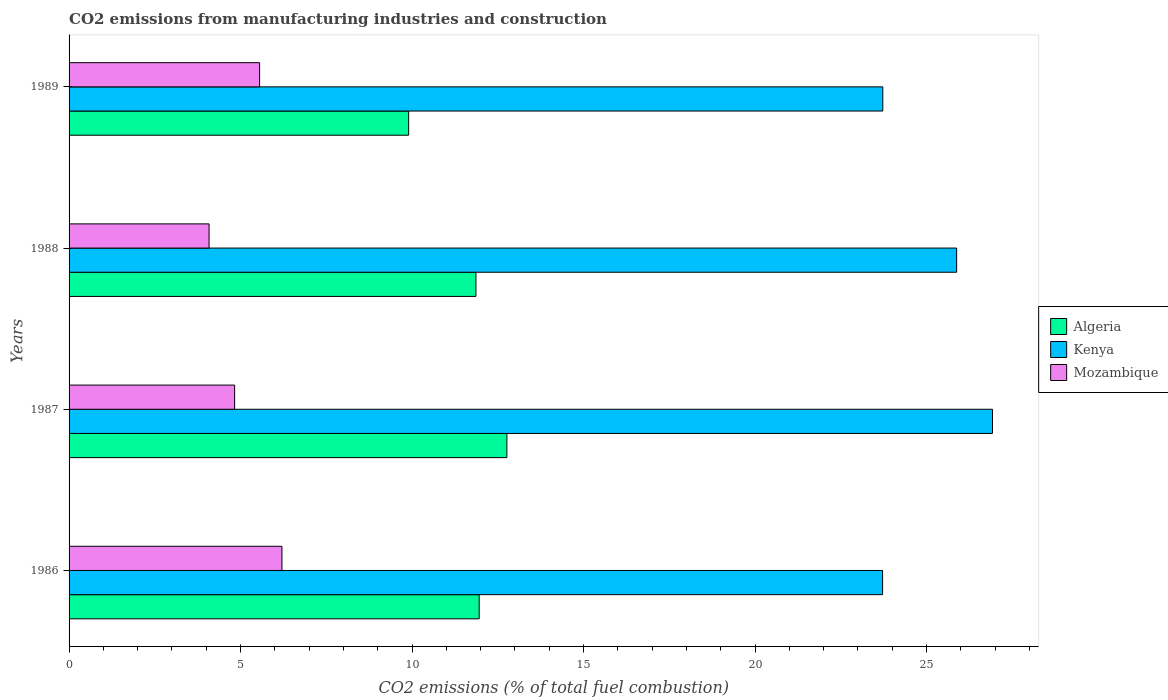How many groups of bars are there?
Your response must be concise. 4. Are the number of bars per tick equal to the number of legend labels?
Make the answer very short. Yes. Are the number of bars on each tick of the Y-axis equal?
Your response must be concise. Yes. How many bars are there on the 3rd tick from the top?
Offer a terse response. 3. What is the label of the 2nd group of bars from the top?
Offer a terse response. 1988. In how many cases, is the number of bars for a given year not equal to the number of legend labels?
Make the answer very short. 0. What is the amount of CO2 emitted in Mozambique in 1989?
Your response must be concise. 5.56. Across all years, what is the maximum amount of CO2 emitted in Algeria?
Provide a short and direct response. 12.77. Across all years, what is the minimum amount of CO2 emitted in Kenya?
Make the answer very short. 23.72. What is the total amount of CO2 emitted in Mozambique in the graph?
Make the answer very short. 20.67. What is the difference between the amount of CO2 emitted in Mozambique in 1986 and that in 1989?
Provide a succinct answer. 0.65. What is the difference between the amount of CO2 emitted in Mozambique in 1988 and the amount of CO2 emitted in Kenya in 1989?
Provide a succinct answer. -19.64. What is the average amount of CO2 emitted in Algeria per year?
Provide a short and direct response. 11.62. In the year 1989, what is the difference between the amount of CO2 emitted in Mozambique and amount of CO2 emitted in Algeria?
Your answer should be compact. -4.35. In how many years, is the amount of CO2 emitted in Kenya greater than 12 %?
Keep it short and to the point. 4. What is the ratio of the amount of CO2 emitted in Kenya in 1986 to that in 1988?
Give a very brief answer. 0.92. Is the difference between the amount of CO2 emitted in Mozambique in 1986 and 1988 greater than the difference between the amount of CO2 emitted in Algeria in 1986 and 1988?
Ensure brevity in your answer.  Yes. What is the difference between the highest and the second highest amount of CO2 emitted in Mozambique?
Your answer should be compact. 0.65. What is the difference between the highest and the lowest amount of CO2 emitted in Algeria?
Your answer should be compact. 2.86. In how many years, is the amount of CO2 emitted in Algeria greater than the average amount of CO2 emitted in Algeria taken over all years?
Your answer should be compact. 3. What does the 1st bar from the top in 1987 represents?
Your response must be concise. Mozambique. What does the 2nd bar from the bottom in 1986 represents?
Provide a succinct answer. Kenya. Is it the case that in every year, the sum of the amount of CO2 emitted in Algeria and amount of CO2 emitted in Kenya is greater than the amount of CO2 emitted in Mozambique?
Your answer should be very brief. Yes. Are all the bars in the graph horizontal?
Offer a very short reply. Yes. Does the graph contain any zero values?
Give a very brief answer. No. Does the graph contain grids?
Keep it short and to the point. No. Where does the legend appear in the graph?
Keep it short and to the point. Center right. What is the title of the graph?
Make the answer very short. CO2 emissions from manufacturing industries and construction. Does "Trinidad and Tobago" appear as one of the legend labels in the graph?
Make the answer very short. No. What is the label or title of the X-axis?
Your response must be concise. CO2 emissions (% of total fuel combustion). What is the CO2 emissions (% of total fuel combustion) in Algeria in 1986?
Provide a short and direct response. 11.96. What is the CO2 emissions (% of total fuel combustion) in Kenya in 1986?
Provide a short and direct response. 23.72. What is the CO2 emissions (% of total fuel combustion) in Mozambique in 1986?
Offer a terse response. 6.21. What is the CO2 emissions (% of total fuel combustion) in Algeria in 1987?
Provide a short and direct response. 12.77. What is the CO2 emissions (% of total fuel combustion) of Kenya in 1987?
Offer a very short reply. 26.92. What is the CO2 emissions (% of total fuel combustion) of Mozambique in 1987?
Make the answer very short. 4.83. What is the CO2 emissions (% of total fuel combustion) in Algeria in 1988?
Provide a short and direct response. 11.86. What is the CO2 emissions (% of total fuel combustion) of Kenya in 1988?
Ensure brevity in your answer.  25.88. What is the CO2 emissions (% of total fuel combustion) of Mozambique in 1988?
Your answer should be very brief. 4.08. What is the CO2 emissions (% of total fuel combustion) in Algeria in 1989?
Make the answer very short. 9.9. What is the CO2 emissions (% of total fuel combustion) in Kenya in 1989?
Offer a terse response. 23.73. What is the CO2 emissions (% of total fuel combustion) of Mozambique in 1989?
Give a very brief answer. 5.56. Across all years, what is the maximum CO2 emissions (% of total fuel combustion) of Algeria?
Your answer should be very brief. 12.77. Across all years, what is the maximum CO2 emissions (% of total fuel combustion) of Kenya?
Offer a very short reply. 26.92. Across all years, what is the maximum CO2 emissions (% of total fuel combustion) in Mozambique?
Give a very brief answer. 6.21. Across all years, what is the minimum CO2 emissions (% of total fuel combustion) of Algeria?
Your answer should be compact. 9.9. Across all years, what is the minimum CO2 emissions (% of total fuel combustion) of Kenya?
Offer a terse response. 23.72. Across all years, what is the minimum CO2 emissions (% of total fuel combustion) of Mozambique?
Your response must be concise. 4.08. What is the total CO2 emissions (% of total fuel combustion) of Algeria in the graph?
Your response must be concise. 46.49. What is the total CO2 emissions (% of total fuel combustion) in Kenya in the graph?
Offer a very short reply. 100.25. What is the total CO2 emissions (% of total fuel combustion) in Mozambique in the graph?
Your answer should be very brief. 20.67. What is the difference between the CO2 emissions (% of total fuel combustion) of Algeria in 1986 and that in 1987?
Keep it short and to the point. -0.81. What is the difference between the CO2 emissions (% of total fuel combustion) of Kenya in 1986 and that in 1987?
Ensure brevity in your answer.  -3.2. What is the difference between the CO2 emissions (% of total fuel combustion) of Mozambique in 1986 and that in 1987?
Give a very brief answer. 1.38. What is the difference between the CO2 emissions (% of total fuel combustion) in Algeria in 1986 and that in 1988?
Offer a very short reply. 0.09. What is the difference between the CO2 emissions (% of total fuel combustion) of Kenya in 1986 and that in 1988?
Your answer should be very brief. -2.16. What is the difference between the CO2 emissions (% of total fuel combustion) of Mozambique in 1986 and that in 1988?
Offer a terse response. 2.13. What is the difference between the CO2 emissions (% of total fuel combustion) in Algeria in 1986 and that in 1989?
Your answer should be very brief. 2.06. What is the difference between the CO2 emissions (% of total fuel combustion) in Kenya in 1986 and that in 1989?
Provide a short and direct response. -0.01. What is the difference between the CO2 emissions (% of total fuel combustion) in Mozambique in 1986 and that in 1989?
Your answer should be very brief. 0.65. What is the difference between the CO2 emissions (% of total fuel combustion) of Algeria in 1987 and that in 1988?
Offer a terse response. 0.9. What is the difference between the CO2 emissions (% of total fuel combustion) in Kenya in 1987 and that in 1988?
Make the answer very short. 1.05. What is the difference between the CO2 emissions (% of total fuel combustion) of Mozambique in 1987 and that in 1988?
Offer a terse response. 0.75. What is the difference between the CO2 emissions (% of total fuel combustion) of Algeria in 1987 and that in 1989?
Provide a succinct answer. 2.86. What is the difference between the CO2 emissions (% of total fuel combustion) in Kenya in 1987 and that in 1989?
Your answer should be compact. 3.2. What is the difference between the CO2 emissions (% of total fuel combustion) of Mozambique in 1987 and that in 1989?
Provide a succinct answer. -0.73. What is the difference between the CO2 emissions (% of total fuel combustion) of Algeria in 1988 and that in 1989?
Provide a short and direct response. 1.96. What is the difference between the CO2 emissions (% of total fuel combustion) of Kenya in 1988 and that in 1989?
Give a very brief answer. 2.15. What is the difference between the CO2 emissions (% of total fuel combustion) of Mozambique in 1988 and that in 1989?
Offer a terse response. -1.47. What is the difference between the CO2 emissions (% of total fuel combustion) in Algeria in 1986 and the CO2 emissions (% of total fuel combustion) in Kenya in 1987?
Your answer should be compact. -14.97. What is the difference between the CO2 emissions (% of total fuel combustion) of Algeria in 1986 and the CO2 emissions (% of total fuel combustion) of Mozambique in 1987?
Give a very brief answer. 7.13. What is the difference between the CO2 emissions (% of total fuel combustion) in Kenya in 1986 and the CO2 emissions (% of total fuel combustion) in Mozambique in 1987?
Offer a very short reply. 18.89. What is the difference between the CO2 emissions (% of total fuel combustion) in Algeria in 1986 and the CO2 emissions (% of total fuel combustion) in Kenya in 1988?
Ensure brevity in your answer.  -13.92. What is the difference between the CO2 emissions (% of total fuel combustion) of Algeria in 1986 and the CO2 emissions (% of total fuel combustion) of Mozambique in 1988?
Your answer should be very brief. 7.88. What is the difference between the CO2 emissions (% of total fuel combustion) in Kenya in 1986 and the CO2 emissions (% of total fuel combustion) in Mozambique in 1988?
Your response must be concise. 19.64. What is the difference between the CO2 emissions (% of total fuel combustion) in Algeria in 1986 and the CO2 emissions (% of total fuel combustion) in Kenya in 1989?
Make the answer very short. -11.77. What is the difference between the CO2 emissions (% of total fuel combustion) of Algeria in 1986 and the CO2 emissions (% of total fuel combustion) of Mozambique in 1989?
Provide a succinct answer. 6.4. What is the difference between the CO2 emissions (% of total fuel combustion) of Kenya in 1986 and the CO2 emissions (% of total fuel combustion) of Mozambique in 1989?
Keep it short and to the point. 18.16. What is the difference between the CO2 emissions (% of total fuel combustion) of Algeria in 1987 and the CO2 emissions (% of total fuel combustion) of Kenya in 1988?
Provide a succinct answer. -13.11. What is the difference between the CO2 emissions (% of total fuel combustion) of Algeria in 1987 and the CO2 emissions (% of total fuel combustion) of Mozambique in 1988?
Make the answer very short. 8.68. What is the difference between the CO2 emissions (% of total fuel combustion) of Kenya in 1987 and the CO2 emissions (% of total fuel combustion) of Mozambique in 1988?
Give a very brief answer. 22.84. What is the difference between the CO2 emissions (% of total fuel combustion) of Algeria in 1987 and the CO2 emissions (% of total fuel combustion) of Kenya in 1989?
Keep it short and to the point. -10.96. What is the difference between the CO2 emissions (% of total fuel combustion) in Algeria in 1987 and the CO2 emissions (% of total fuel combustion) in Mozambique in 1989?
Make the answer very short. 7.21. What is the difference between the CO2 emissions (% of total fuel combustion) in Kenya in 1987 and the CO2 emissions (% of total fuel combustion) in Mozambique in 1989?
Your answer should be compact. 21.37. What is the difference between the CO2 emissions (% of total fuel combustion) of Algeria in 1988 and the CO2 emissions (% of total fuel combustion) of Kenya in 1989?
Offer a terse response. -11.86. What is the difference between the CO2 emissions (% of total fuel combustion) in Algeria in 1988 and the CO2 emissions (% of total fuel combustion) in Mozambique in 1989?
Offer a terse response. 6.31. What is the difference between the CO2 emissions (% of total fuel combustion) of Kenya in 1988 and the CO2 emissions (% of total fuel combustion) of Mozambique in 1989?
Ensure brevity in your answer.  20.32. What is the average CO2 emissions (% of total fuel combustion) of Algeria per year?
Your answer should be compact. 11.62. What is the average CO2 emissions (% of total fuel combustion) of Kenya per year?
Provide a short and direct response. 25.06. What is the average CO2 emissions (% of total fuel combustion) of Mozambique per year?
Keep it short and to the point. 5.17. In the year 1986, what is the difference between the CO2 emissions (% of total fuel combustion) in Algeria and CO2 emissions (% of total fuel combustion) in Kenya?
Provide a succinct answer. -11.76. In the year 1986, what is the difference between the CO2 emissions (% of total fuel combustion) of Algeria and CO2 emissions (% of total fuel combustion) of Mozambique?
Give a very brief answer. 5.75. In the year 1986, what is the difference between the CO2 emissions (% of total fuel combustion) of Kenya and CO2 emissions (% of total fuel combustion) of Mozambique?
Ensure brevity in your answer.  17.51. In the year 1987, what is the difference between the CO2 emissions (% of total fuel combustion) in Algeria and CO2 emissions (% of total fuel combustion) in Kenya?
Keep it short and to the point. -14.16. In the year 1987, what is the difference between the CO2 emissions (% of total fuel combustion) in Algeria and CO2 emissions (% of total fuel combustion) in Mozambique?
Your response must be concise. 7.94. In the year 1987, what is the difference between the CO2 emissions (% of total fuel combustion) of Kenya and CO2 emissions (% of total fuel combustion) of Mozambique?
Make the answer very short. 22.1. In the year 1988, what is the difference between the CO2 emissions (% of total fuel combustion) in Algeria and CO2 emissions (% of total fuel combustion) in Kenya?
Ensure brevity in your answer.  -14.01. In the year 1988, what is the difference between the CO2 emissions (% of total fuel combustion) in Algeria and CO2 emissions (% of total fuel combustion) in Mozambique?
Make the answer very short. 7.78. In the year 1988, what is the difference between the CO2 emissions (% of total fuel combustion) in Kenya and CO2 emissions (% of total fuel combustion) in Mozambique?
Your answer should be compact. 21.8. In the year 1989, what is the difference between the CO2 emissions (% of total fuel combustion) in Algeria and CO2 emissions (% of total fuel combustion) in Kenya?
Offer a very short reply. -13.82. In the year 1989, what is the difference between the CO2 emissions (% of total fuel combustion) of Algeria and CO2 emissions (% of total fuel combustion) of Mozambique?
Provide a succinct answer. 4.35. In the year 1989, what is the difference between the CO2 emissions (% of total fuel combustion) of Kenya and CO2 emissions (% of total fuel combustion) of Mozambique?
Your answer should be compact. 18.17. What is the ratio of the CO2 emissions (% of total fuel combustion) in Algeria in 1986 to that in 1987?
Make the answer very short. 0.94. What is the ratio of the CO2 emissions (% of total fuel combustion) of Kenya in 1986 to that in 1987?
Provide a succinct answer. 0.88. What is the ratio of the CO2 emissions (% of total fuel combustion) of Algeria in 1986 to that in 1988?
Your answer should be very brief. 1.01. What is the ratio of the CO2 emissions (% of total fuel combustion) of Kenya in 1986 to that in 1988?
Offer a very short reply. 0.92. What is the ratio of the CO2 emissions (% of total fuel combustion) of Mozambique in 1986 to that in 1988?
Give a very brief answer. 1.52. What is the ratio of the CO2 emissions (% of total fuel combustion) in Algeria in 1986 to that in 1989?
Ensure brevity in your answer.  1.21. What is the ratio of the CO2 emissions (% of total fuel combustion) of Mozambique in 1986 to that in 1989?
Give a very brief answer. 1.12. What is the ratio of the CO2 emissions (% of total fuel combustion) in Algeria in 1987 to that in 1988?
Make the answer very short. 1.08. What is the ratio of the CO2 emissions (% of total fuel combustion) in Kenya in 1987 to that in 1988?
Your response must be concise. 1.04. What is the ratio of the CO2 emissions (% of total fuel combustion) in Mozambique in 1987 to that in 1988?
Provide a short and direct response. 1.18. What is the ratio of the CO2 emissions (% of total fuel combustion) of Algeria in 1987 to that in 1989?
Your answer should be compact. 1.29. What is the ratio of the CO2 emissions (% of total fuel combustion) in Kenya in 1987 to that in 1989?
Your response must be concise. 1.13. What is the ratio of the CO2 emissions (% of total fuel combustion) in Mozambique in 1987 to that in 1989?
Make the answer very short. 0.87. What is the ratio of the CO2 emissions (% of total fuel combustion) in Algeria in 1988 to that in 1989?
Make the answer very short. 1.2. What is the ratio of the CO2 emissions (% of total fuel combustion) in Kenya in 1988 to that in 1989?
Keep it short and to the point. 1.09. What is the ratio of the CO2 emissions (% of total fuel combustion) of Mozambique in 1988 to that in 1989?
Your answer should be very brief. 0.73. What is the difference between the highest and the second highest CO2 emissions (% of total fuel combustion) of Algeria?
Your response must be concise. 0.81. What is the difference between the highest and the second highest CO2 emissions (% of total fuel combustion) of Kenya?
Provide a succinct answer. 1.05. What is the difference between the highest and the second highest CO2 emissions (% of total fuel combustion) in Mozambique?
Offer a terse response. 0.65. What is the difference between the highest and the lowest CO2 emissions (% of total fuel combustion) of Algeria?
Make the answer very short. 2.86. What is the difference between the highest and the lowest CO2 emissions (% of total fuel combustion) in Kenya?
Your response must be concise. 3.2. What is the difference between the highest and the lowest CO2 emissions (% of total fuel combustion) of Mozambique?
Offer a very short reply. 2.13. 